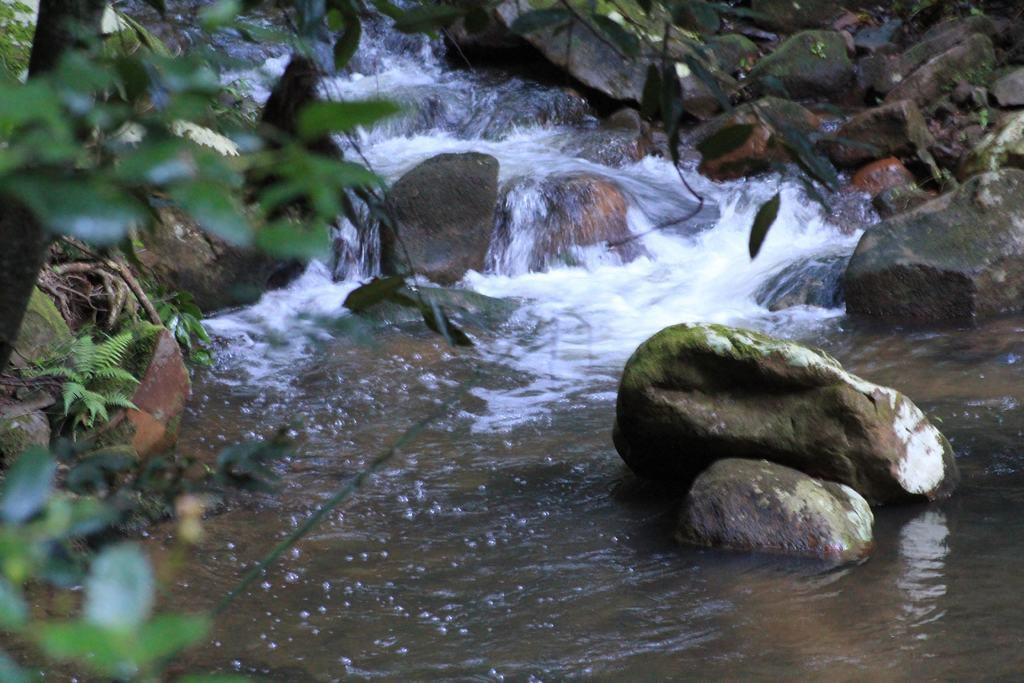What type of natural elements can be seen in the image? There are trees and stones visible in the image. What is the water doing in the image? There is water flow visible in the image. What is the purpose of the laughter in the image? There is no laughter present in the image; it only features trees, stones, and water flow. 